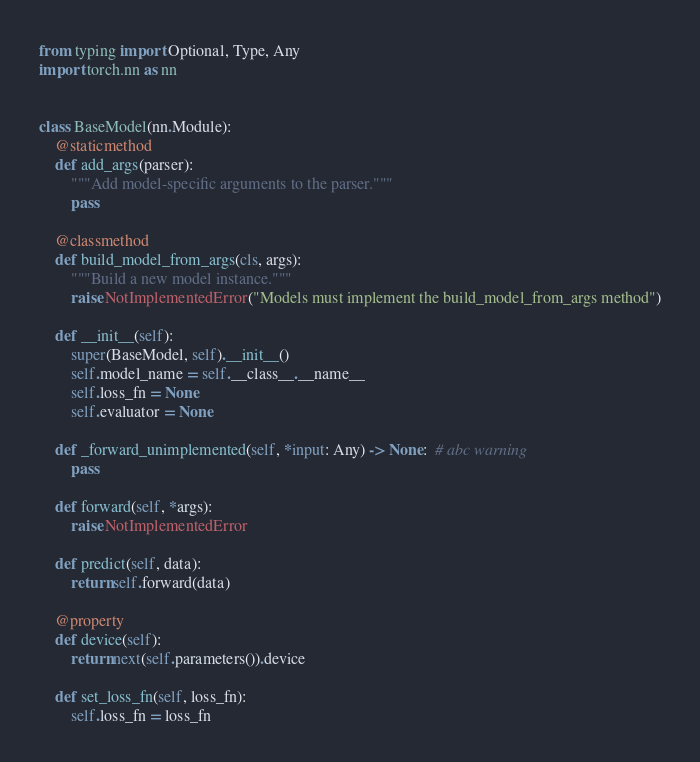Convert code to text. <code><loc_0><loc_0><loc_500><loc_500><_Python_>from typing import Optional, Type, Any
import torch.nn as nn


class BaseModel(nn.Module):
    @staticmethod
    def add_args(parser):
        """Add model-specific arguments to the parser."""
        pass

    @classmethod
    def build_model_from_args(cls, args):
        """Build a new model instance."""
        raise NotImplementedError("Models must implement the build_model_from_args method")

    def __init__(self):
        super(BaseModel, self).__init__()
        self.model_name = self.__class__.__name__
        self.loss_fn = None
        self.evaluator = None

    def _forward_unimplemented(self, *input: Any) -> None:  # abc warning
        pass

    def forward(self, *args):
        raise NotImplementedError

    def predict(self, data):
        return self.forward(data)

    @property
    def device(self):
        return next(self.parameters()).device

    def set_loss_fn(self, loss_fn):
        self.loss_fn = loss_fn
</code> 